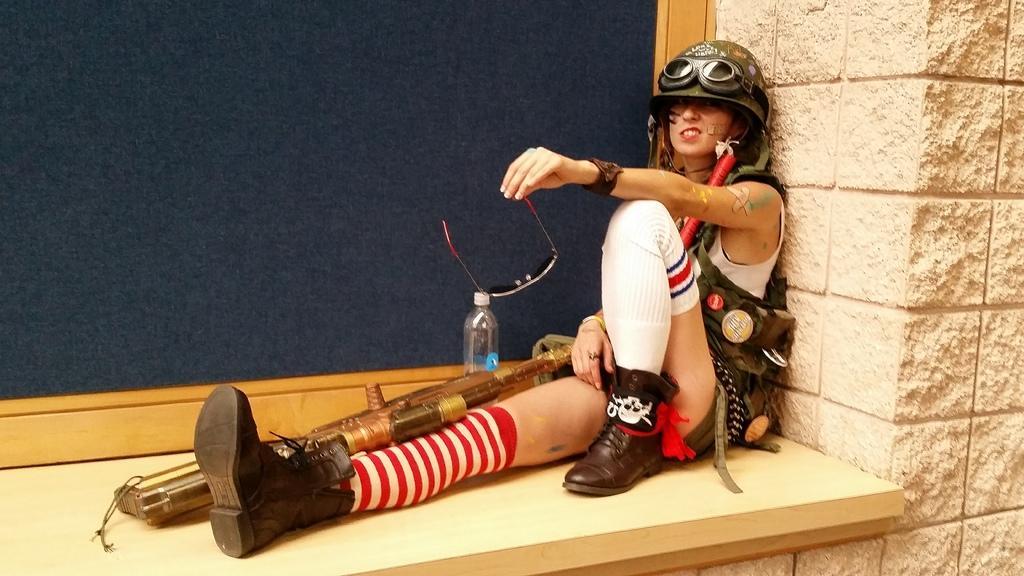In one or two sentences, can you explain what this image depicts? In this image I can see a person wearing helmet and holding goggles. To the right of her there is a bottle. 